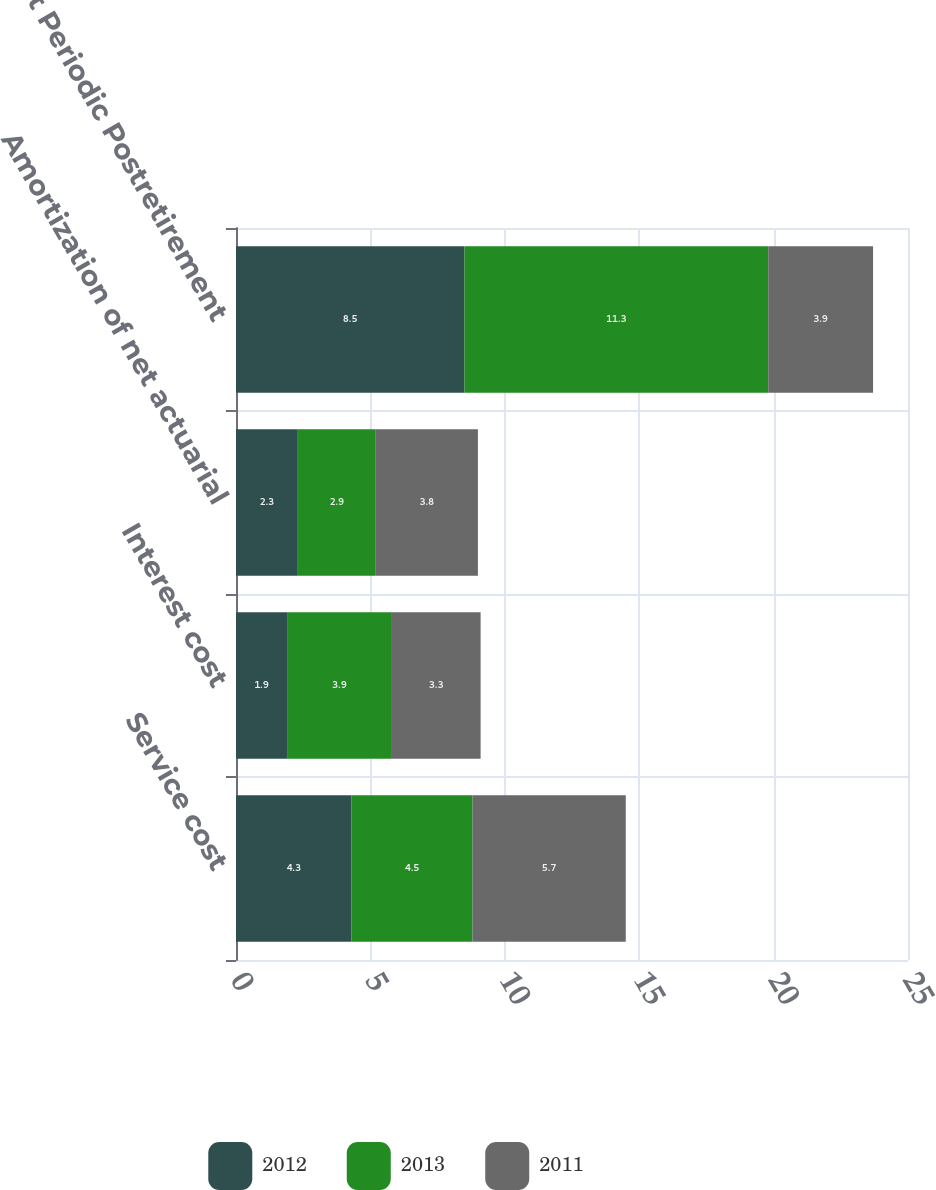<chart> <loc_0><loc_0><loc_500><loc_500><stacked_bar_chart><ecel><fcel>Service cost<fcel>Interest cost<fcel>Amortization of net actuarial<fcel>Net Periodic Postretirement<nl><fcel>2012<fcel>4.3<fcel>1.9<fcel>2.3<fcel>8.5<nl><fcel>2013<fcel>4.5<fcel>3.9<fcel>2.9<fcel>11.3<nl><fcel>2011<fcel>5.7<fcel>3.3<fcel>3.8<fcel>3.9<nl></chart> 